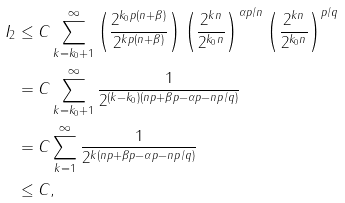Convert formula to latex. <formula><loc_0><loc_0><loc_500><loc_500>I _ { 2 } & \leq C \sum _ { k = k _ { 0 } + 1 } ^ { \infty } \left ( \frac { 2 ^ { k _ { 0 } p ( n + \beta ) } } { 2 ^ { k p ( n + \beta ) } } \right ) \left ( \frac { 2 ^ { k n } } { 2 ^ { k _ { 0 } n } } \right ) ^ { { \alpha p } / n } \left ( \frac { 2 ^ { k n } } { 2 ^ { k _ { 0 } n } } \right ) ^ { p / q } \\ & = C \sum _ { k = k _ { 0 } + 1 } ^ { \infty } \frac { 1 } { 2 ^ { ( k - k _ { 0 } ) ( n p + \beta p - \alpha p - { n p } / q ) } } \\ & = C \sum _ { k = 1 } ^ { \infty } \frac { 1 } { 2 ^ { k ( n p + \beta p - \alpha p - { n p } / q ) } } \\ & \leq C ,</formula> 